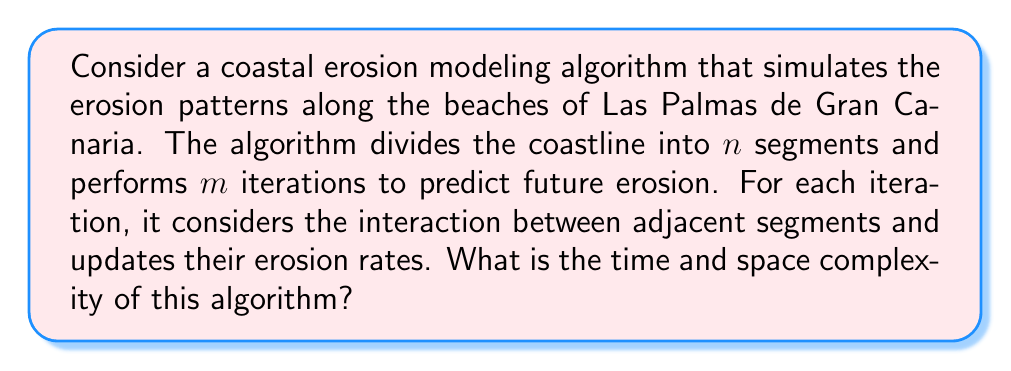Solve this math problem. To analyze the time and space complexity of this coastal erosion modeling algorithm, let's break it down step by step:

1. Time Complexity:
   a. The coastline is divided into $n$ segments.
   b. The algorithm performs $m$ iterations.
   c. For each iteration, it processes each segment and its adjacent segments.

   - Processing each segment requires checking its two adjacent segments (except for the endpoints).
   - This results in approximately $3n$ operations per iteration.
   - The total number of operations is thus $m \times 3n$.

   Therefore, the time complexity is $O(mn)$.

2. Space Complexity:
   a. We need to store information for each of the $n$ segments.
   b. For each segment, we likely need to store at least:
      - Current erosion rate
      - Position or coordinates
      - Any other relevant parameters (e.g., soil type, wave exposure)

   Let's assume we need a constant amount of space $k$ for each segment.
   
   The total space required is then $n \times k$, which simplifies to $O(n)$.

3. Additional Considerations:
   - If the algorithm needs to store the state of the coastline for each iteration (for example, to visualize the erosion process over time), the space complexity would increase to $O(mn)$.
   - If more complex interactions between segments are considered (e.g., beyond just adjacent segments), the time complexity could increase.

In the context of Las Palmas de Gran Canaria, this algorithm could be crucial for predicting erosion patterns along beaches like Playa de Las Canteras or Playa de La Laja, helping to protect these important natural and cultural heritage sites.
Answer: Time Complexity: $O(mn)$
Space Complexity: $O(n)$ 